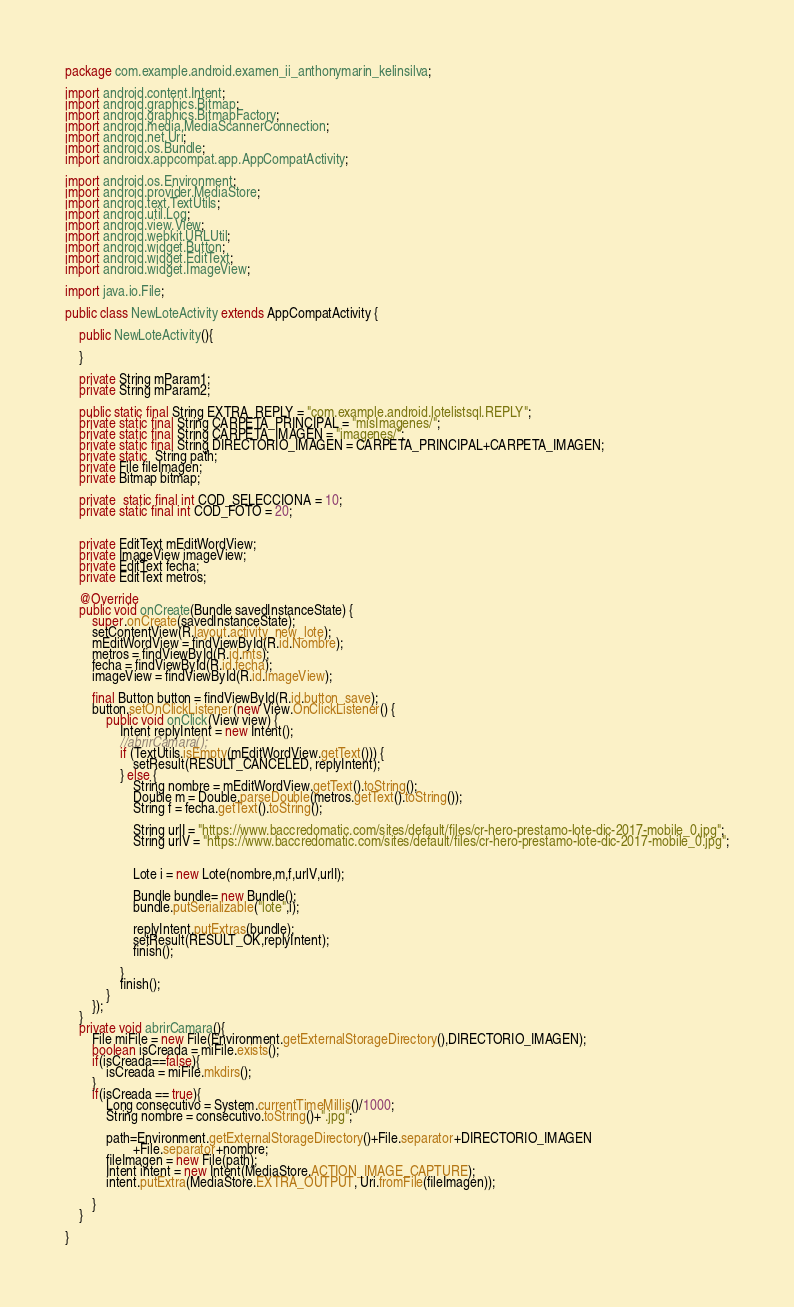Convert code to text. <code><loc_0><loc_0><loc_500><loc_500><_Java_>package com.example.android.examen_ii_anthonymarin_kelinsilva;

import android.content.Intent;
import android.graphics.Bitmap;
import android.graphics.BitmapFactory;
import android.media.MediaScannerConnection;
import android.net.Uri;
import android.os.Bundle;
import androidx.appcompat.app.AppCompatActivity;

import android.os.Environment;
import android.provider.MediaStore;
import android.text.TextUtils;
import android.util.Log;
import android.view.View;
import android.webkit.URLUtil;
import android.widget.Button;
import android.widget.EditText;
import android.widget.ImageView;

import java.io.File;

public class NewLoteActivity extends AppCompatActivity {

    public NewLoteActivity(){

    }

    private String mParam1;
    private String mParam2;

    public static final String EXTRA_REPLY = "com.example.android.lotelistsql.REPLY";
    private static final String CARPETA_PRINCIPAL = "misImagenes/";
    private static final String CARPETA_IMAGEN = "imagenes/";
    private static final String DIRECTORIO_IMAGEN = CARPETA_PRINCIPAL+CARPETA_IMAGEN;
    private static  String path;
    private File fileImagen;
    private Bitmap bitmap;

    private  static final int COD_SELECCIONA = 10;
    private static final int COD_FOTO = 20;


    private EditText mEditWordView;
    private ImageView imageView;
    private EditText fecha;
    private EditText metros;

    @Override
    public void onCreate(Bundle savedInstanceState) {
        super.onCreate(savedInstanceState);
        setContentView(R.layout.activity_new_lote);
        mEditWordView = findViewById(R.id.Nombre);
        metros = findViewById(R.id.mts);
        fecha = findViewById(R.id.fecha);
        imageView = findViewById(R.id.imageView);

        final Button button = findViewById(R.id.button_save);
        button.setOnClickListener(new View.OnClickListener() {
            public void onClick(View view) {
                Intent replyIntent = new Intent();
                //abrirCamara();
                if (TextUtils.isEmpty(mEditWordView.getText())) {
                    setResult(RESULT_CANCELED, replyIntent);
                } else {
                    String nombre = mEditWordView.getText().toString();
                    Double m = Double.parseDouble(metros.getText().toString());
                    String f = fecha.getText().toString();

                    String urlI = "https://www.baccredomatic.com/sites/default/files/cr-hero-prestamo-lote-dic-2017-mobile_0.jpg";
                    String urlV = "https://www.baccredomatic.com/sites/default/files/cr-hero-prestamo-lote-dic-2017-mobile_0.jpg";


                    Lote i = new Lote(nombre,m,f,urlV,urlI);

                    Bundle bundle= new Bundle();
                    bundle.putSerializable("lote",i);

                    replyIntent.putExtras(bundle);
                    setResult(RESULT_OK,replyIntent);
                    finish();

                }
                finish();
            }
        });
    }
    private void abrirCamara(){
        File miFile = new File(Environment.getExternalStorageDirectory(),DIRECTORIO_IMAGEN);
        boolean isCreada = miFile.exists();
        if(isCreada==false){
            isCreada = miFile.mkdirs();
        }
        if(isCreada == true){
            Long consecutivo = System.currentTimeMillis()/1000;
            String nombre = consecutivo.toString()+".jpg";

            path=Environment.getExternalStorageDirectory()+File.separator+DIRECTORIO_IMAGEN
                    +File.separator+nombre;
            fileImagen = new File(path);
            Intent intent = new Intent(MediaStore.ACTION_IMAGE_CAPTURE);
            intent.putExtra(MediaStore.EXTRA_OUTPUT, Uri.fromFile(fileImagen));

        }
    }

}

</code> 